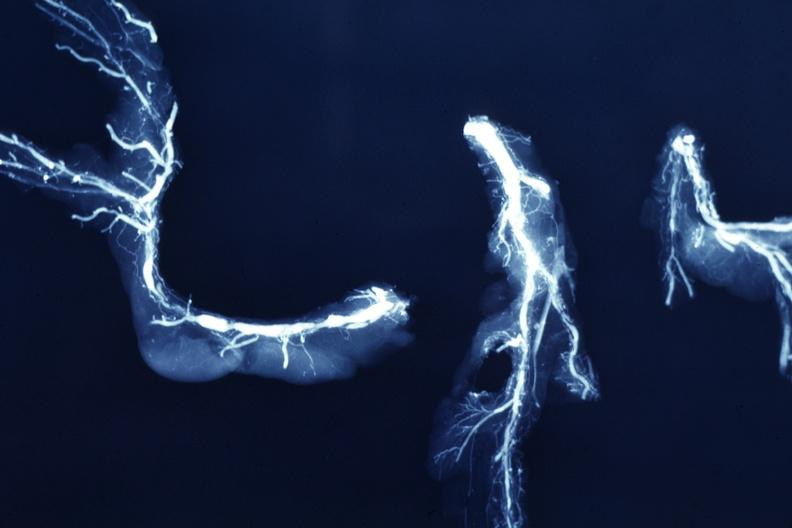what is present?
Answer the question using a single word or phrase. Cardiovascular 